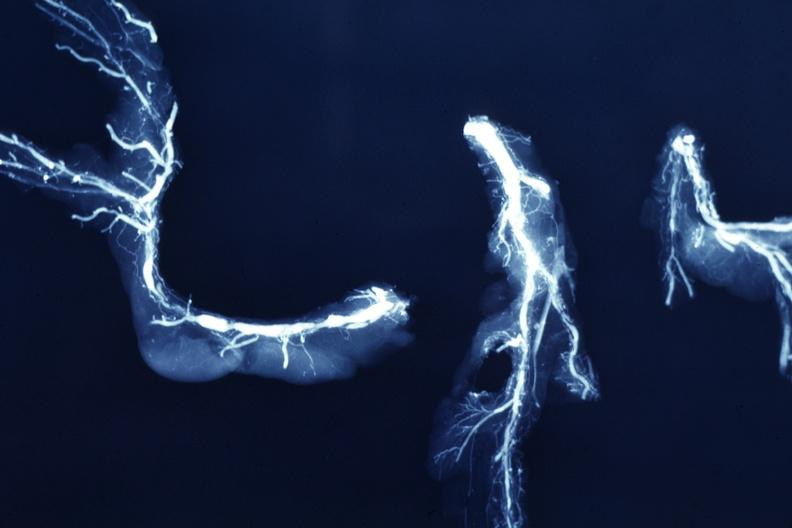what is present?
Answer the question using a single word or phrase. Cardiovascular 